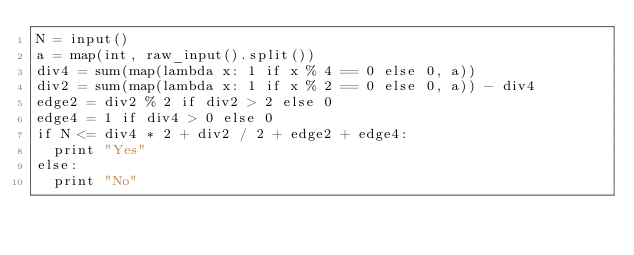Convert code to text. <code><loc_0><loc_0><loc_500><loc_500><_Python_>N = input()
a = map(int, raw_input().split())
div4 = sum(map(lambda x: 1 if x % 4 == 0 else 0, a))
div2 = sum(map(lambda x: 1 if x % 2 == 0 else 0, a)) - div4
edge2 = div2 % 2 if div2 > 2 else 0
edge4 = 1 if div4 > 0 else 0
if N <= div4 * 2 + div2 / 2 + edge2 + edge4:
  print "Yes"
else:
  print "No"
</code> 